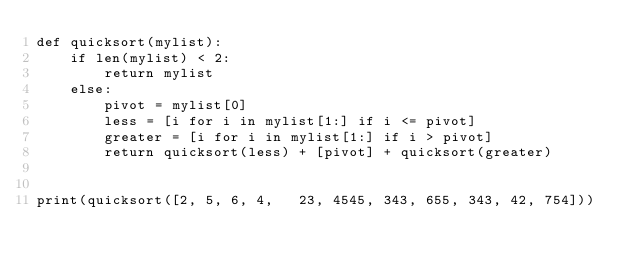Convert code to text. <code><loc_0><loc_0><loc_500><loc_500><_Python_>def quicksort(mylist):
    if len(mylist) < 2:
        return mylist
    else:
        pivot = mylist[0]
        less = [i for i in mylist[1:] if i <= pivot]
        greater = [i for i in mylist[1:] if i > pivot]
        return quicksort(less) + [pivot] + quicksort(greater)


print(quicksort([2, 5, 6, 4,   23, 4545, 343, 655, 343, 42, 754]))
</code> 